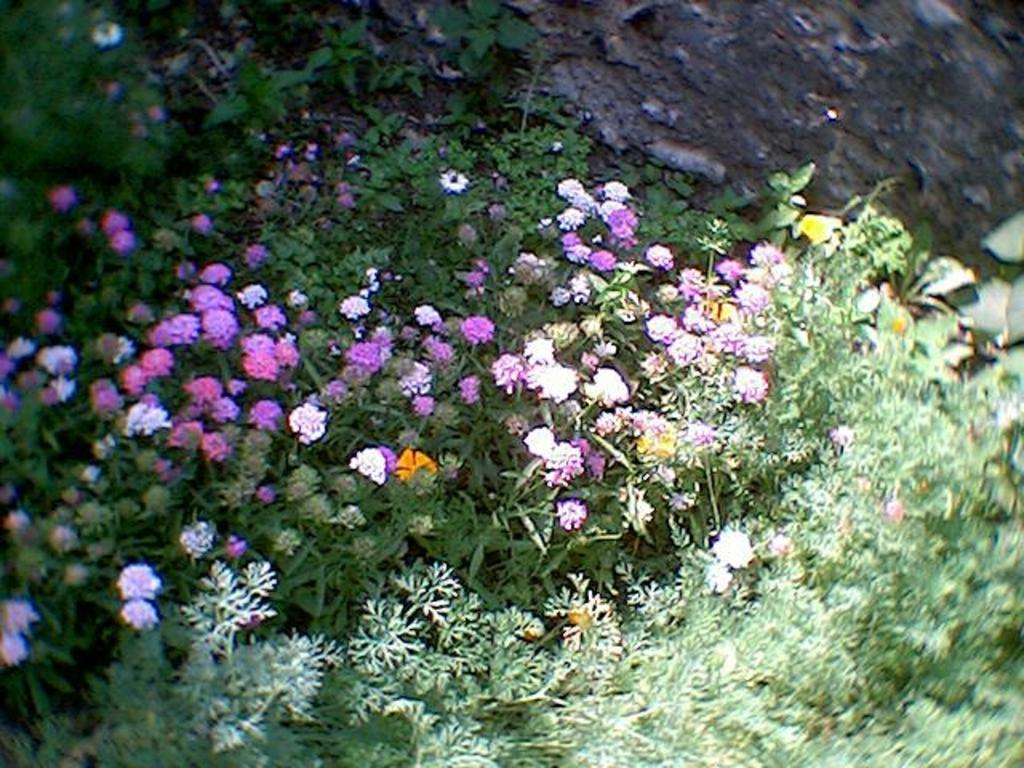What type of plants can be seen in the image? There are floral plants in the image. What type of drug can be seen in the image? There is no drug present in the image; it features floral plants. 